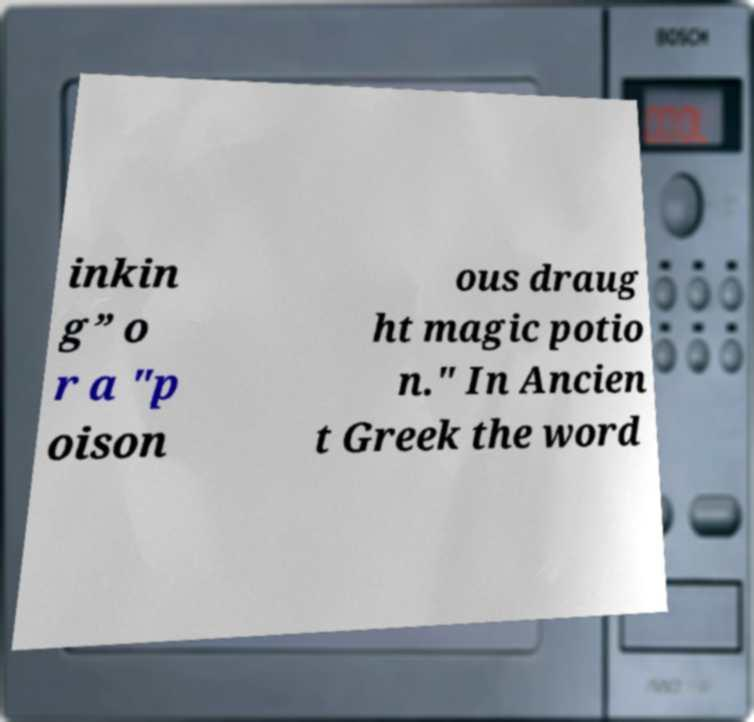Can you accurately transcribe the text from the provided image for me? inkin g” o r a "p oison ous draug ht magic potio n." In Ancien t Greek the word 